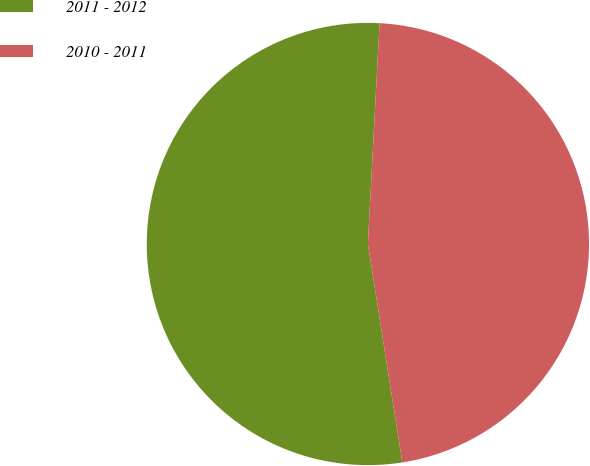Convert chart to OTSL. <chart><loc_0><loc_0><loc_500><loc_500><pie_chart><fcel>2011 - 2012<fcel>2010 - 2011<nl><fcel>53.33%<fcel>46.67%<nl></chart> 